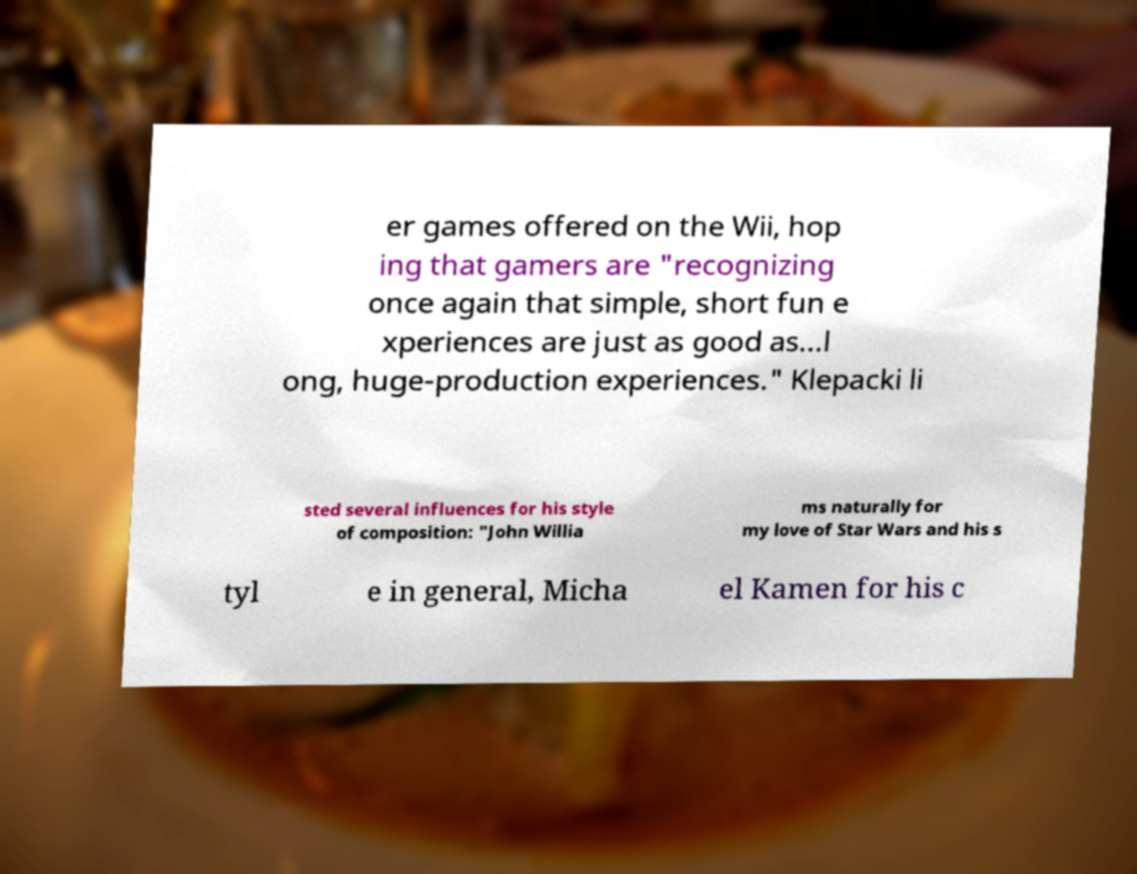Can you read and provide the text displayed in the image?This photo seems to have some interesting text. Can you extract and type it out for me? er games offered on the Wii, hop ing that gamers are "recognizing once again that simple, short fun e xperiences are just as good as...l ong, huge-production experiences." Klepacki li sted several influences for his style of composition: "John Willia ms naturally for my love of Star Wars and his s tyl e in general, Micha el Kamen for his c 